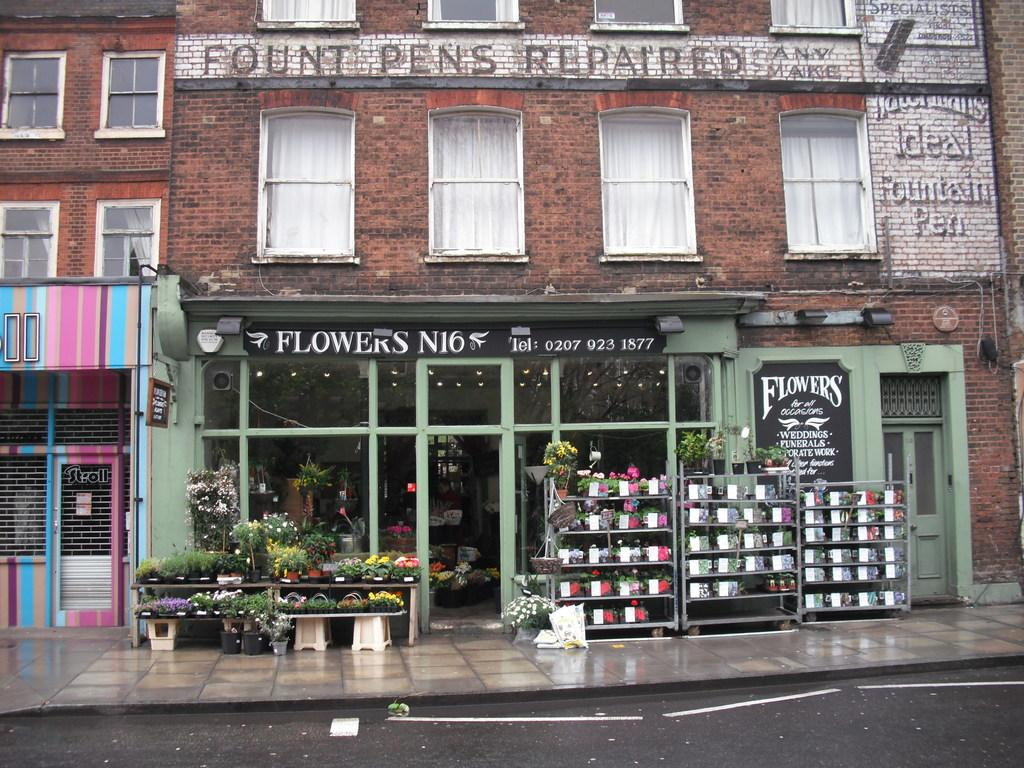<image>
Relay a brief, clear account of the picture shown. A Flower shop advertises that has flowers for all occasions 